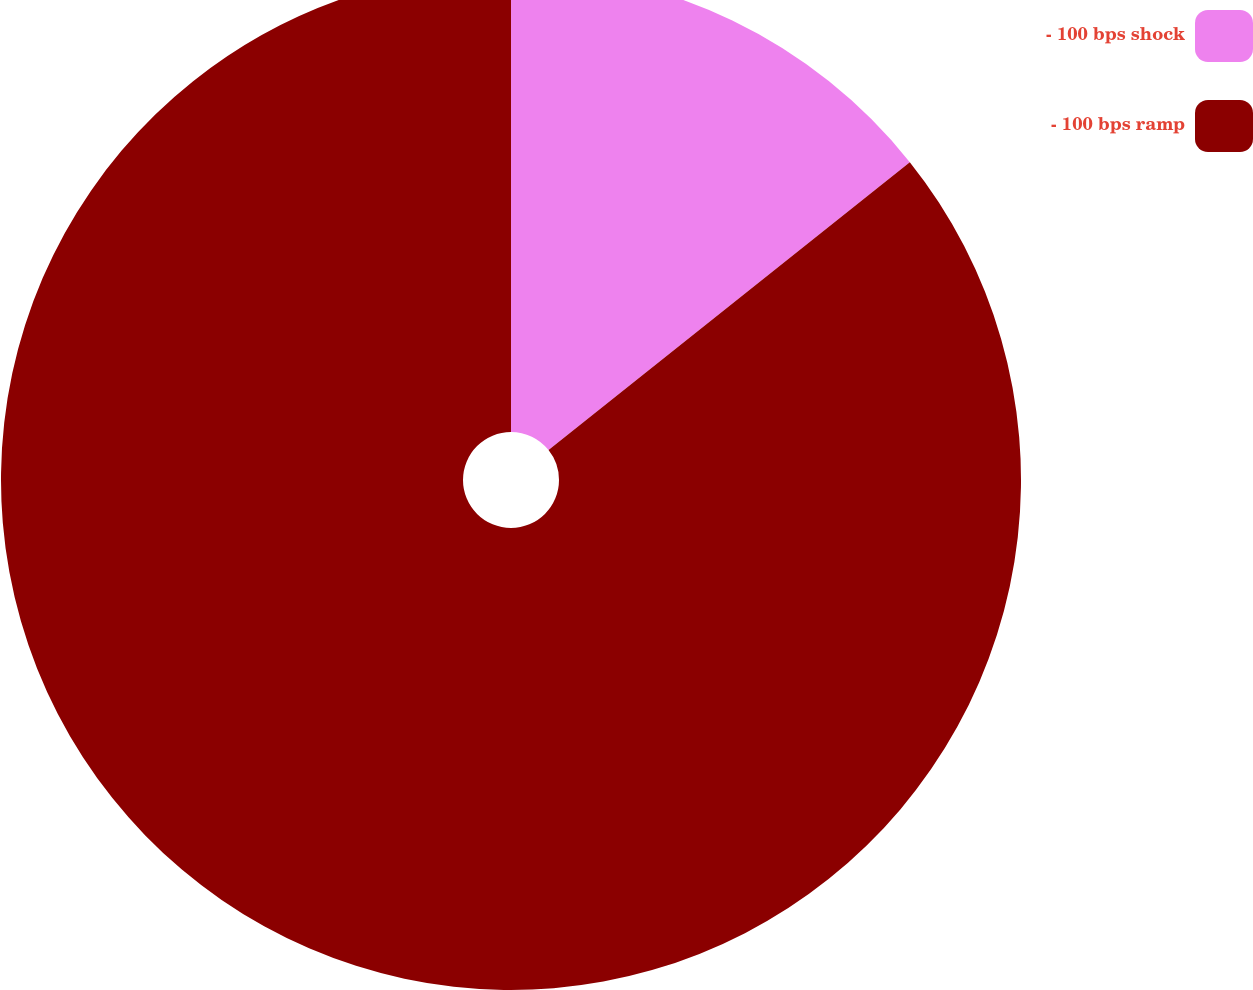Convert chart. <chart><loc_0><loc_0><loc_500><loc_500><pie_chart><fcel>- 100 bps shock<fcel>- 100 bps ramp<nl><fcel>14.29%<fcel>85.71%<nl></chart> 